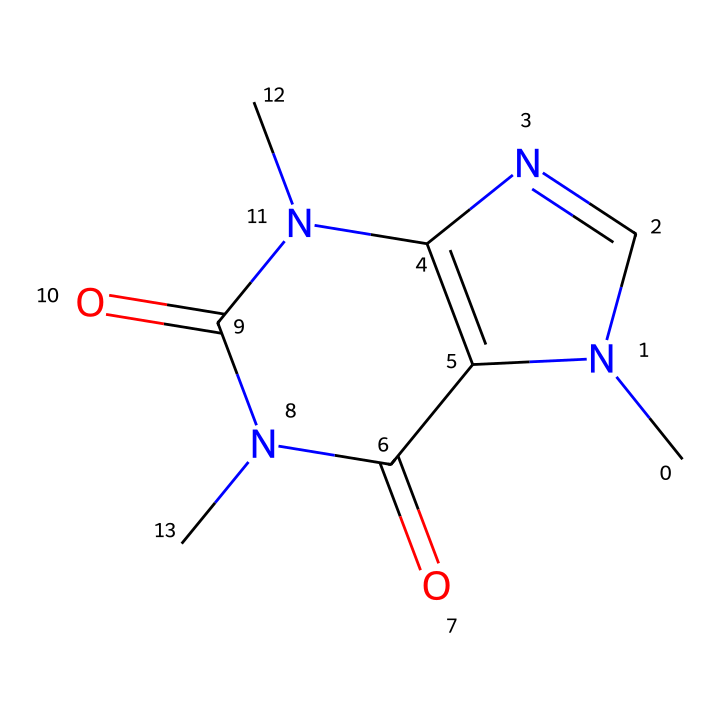What is the name of this chemical? The SMILES provided corresponds to the structure of caffeine, which is a well-known stimulant commonly found in energy drinks and coffee.
Answer: caffeine How many nitrogen atoms are present in this structure? Analyzing the SMILES representation, we can identify three nitrogen atoms indicated by 'N' in the structure, which contribute to the molecular framework of caffeine.
Answer: three What is the total number of carbon atoms in this chemical? By examining the SMILES representation closely, we count five carbon atoms as represented by 'C' along with the connectivity to other atoms within the chemical structure.
Answer: eight Is this chemical classified as a lipid? Caffeine is classified as an alkaloid rather than a lipid; lipids typically include fats and oils, whereas caffeine is a nitrogen-containing compound known for stimulation rather than energy storage.
Answer: no What type of bonding is primarily found in this structure? The structure of caffeine includes both single and double bonds, typical of organic chemicals. The double bonds, particularly in the rings, demonstrate resonance which is essential for the stability of the molecule.
Answer: covalent Does this chemical structure contain any functional groups? The caffeine structure exhibits functional groups such as carbonyl (C=O) and amine (N), as evidenced by their specific bonding patterns in the SMILES representation, contributing to its chemical properties.
Answer: yes What characteristic of caffeine affects its solubility in water? The presence of polar functional groups, particularly the nitrogen and carbonyl groups, enhances the solubility of caffeine in water due to hydrogen bonding capabilities with water molecules.
Answer: polarity 